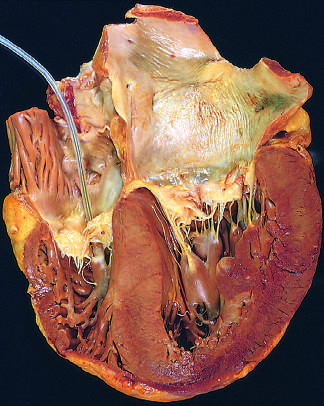where is the pacemaker?
Answer the question using a single word or phrase. In the right ventricle 